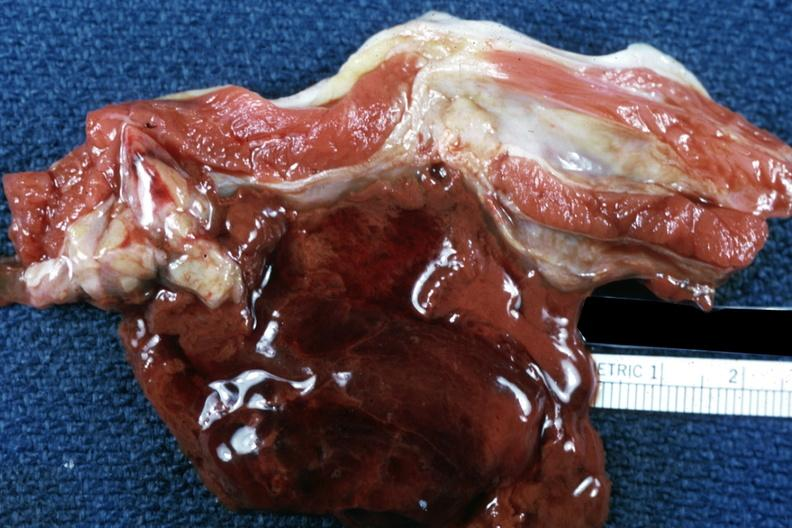s muscle present?
Answer the question using a single word or phrase. Yes 